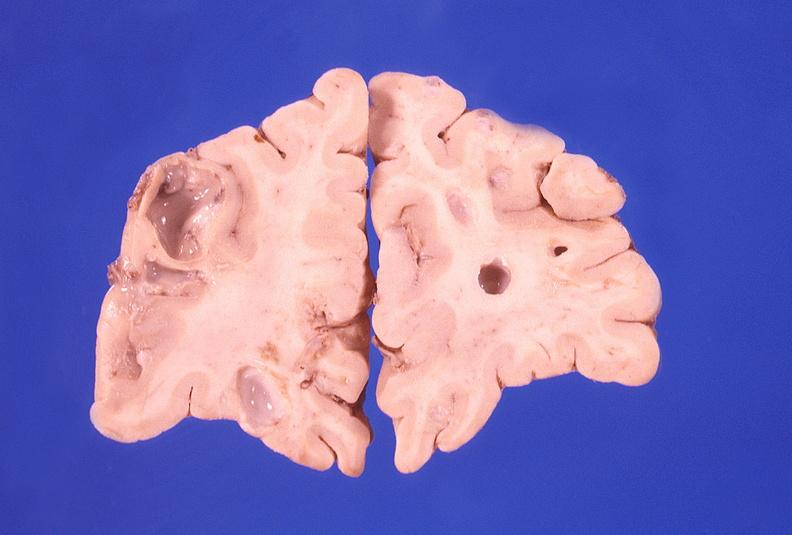does gangrene show brain abscess?
Answer the question using a single word or phrase. No 